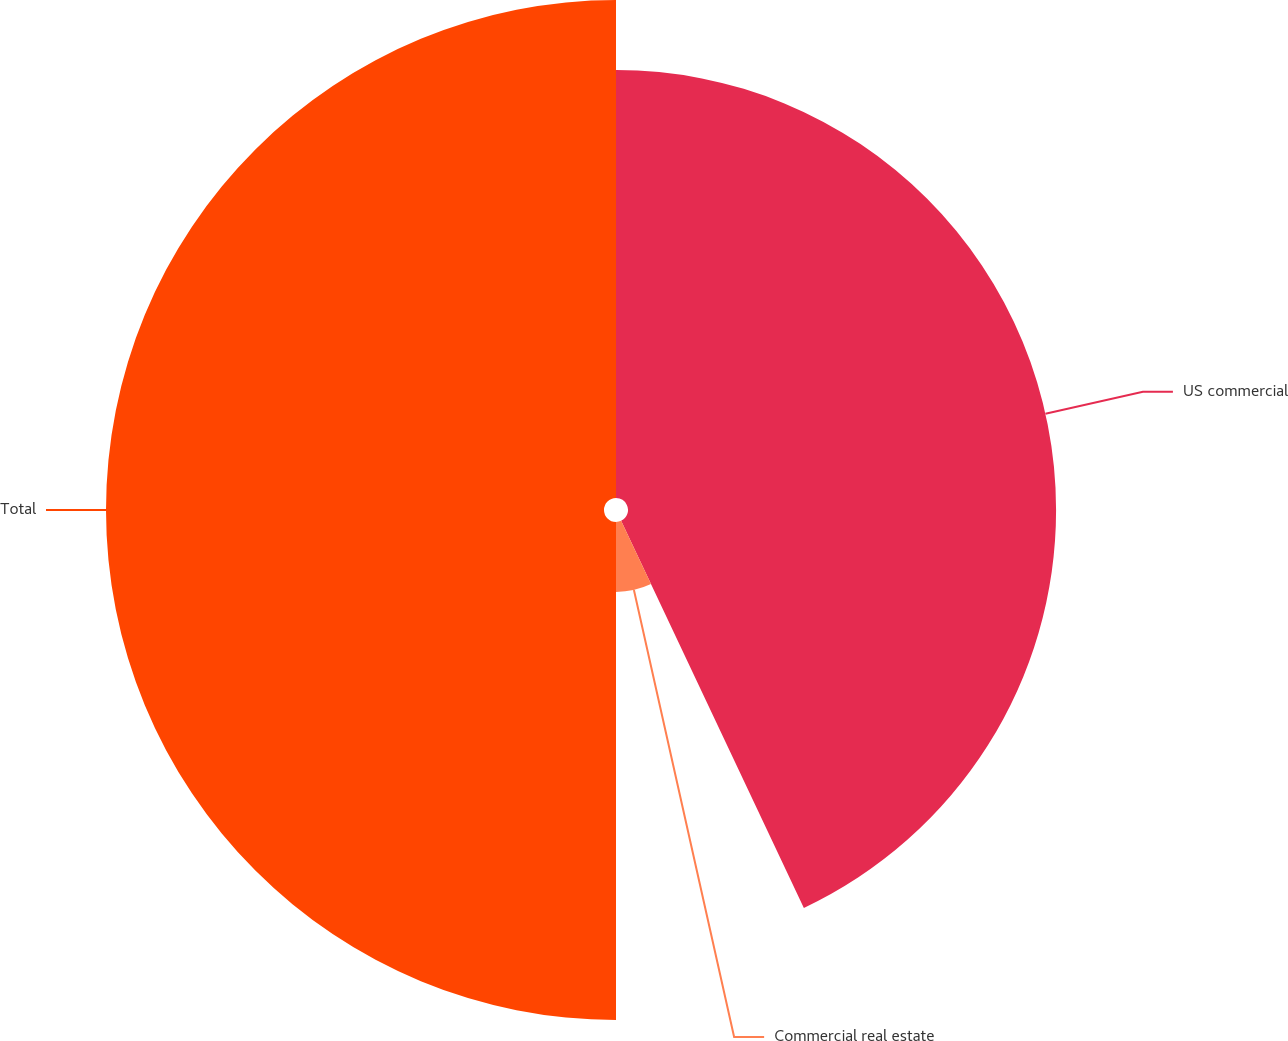Convert chart to OTSL. <chart><loc_0><loc_0><loc_500><loc_500><pie_chart><fcel>US commercial<fcel>Commercial real estate<fcel>Total<nl><fcel>42.98%<fcel>7.02%<fcel>50.0%<nl></chart> 